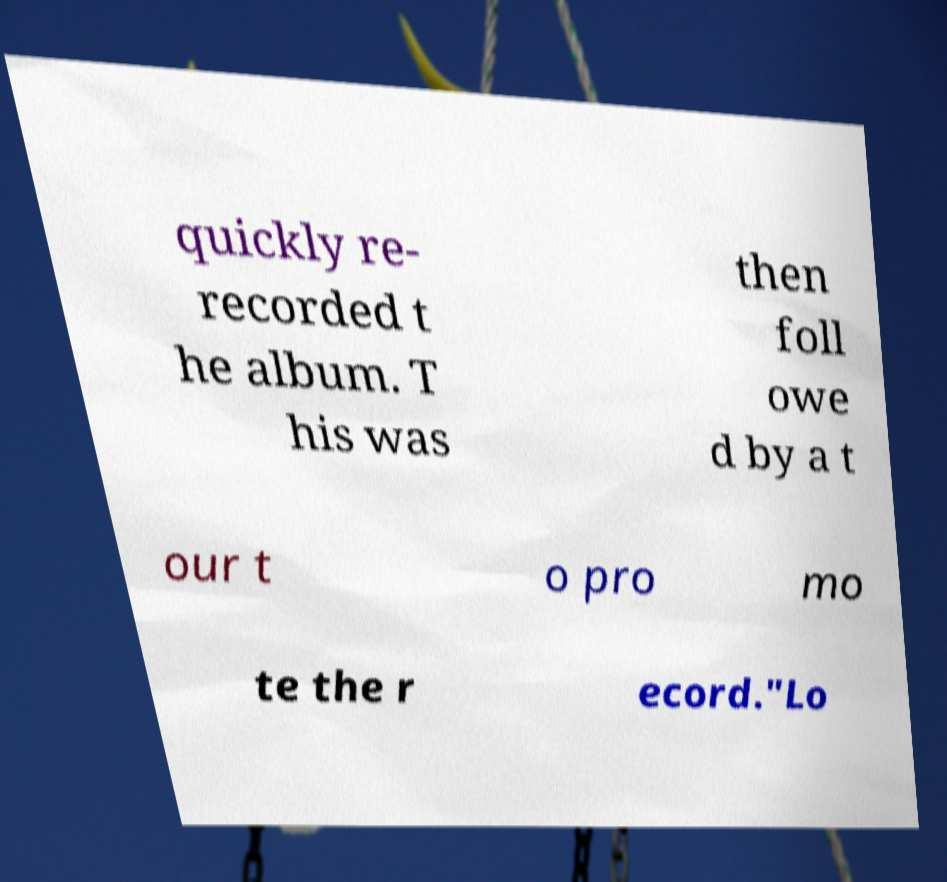Can you read and provide the text displayed in the image?This photo seems to have some interesting text. Can you extract and type it out for me? quickly re- recorded t he album. T his was then foll owe d by a t our t o pro mo te the r ecord."Lo 